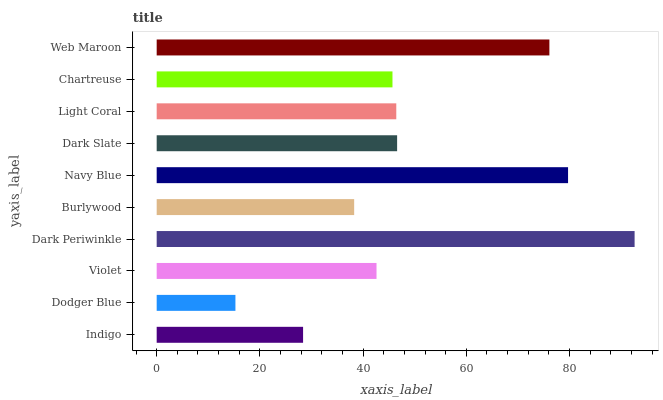Is Dodger Blue the minimum?
Answer yes or no. Yes. Is Dark Periwinkle the maximum?
Answer yes or no. Yes. Is Violet the minimum?
Answer yes or no. No. Is Violet the maximum?
Answer yes or no. No. Is Violet greater than Dodger Blue?
Answer yes or no. Yes. Is Dodger Blue less than Violet?
Answer yes or no. Yes. Is Dodger Blue greater than Violet?
Answer yes or no. No. Is Violet less than Dodger Blue?
Answer yes or no. No. Is Light Coral the high median?
Answer yes or no. Yes. Is Chartreuse the low median?
Answer yes or no. Yes. Is Dodger Blue the high median?
Answer yes or no. No. Is Burlywood the low median?
Answer yes or no. No. 